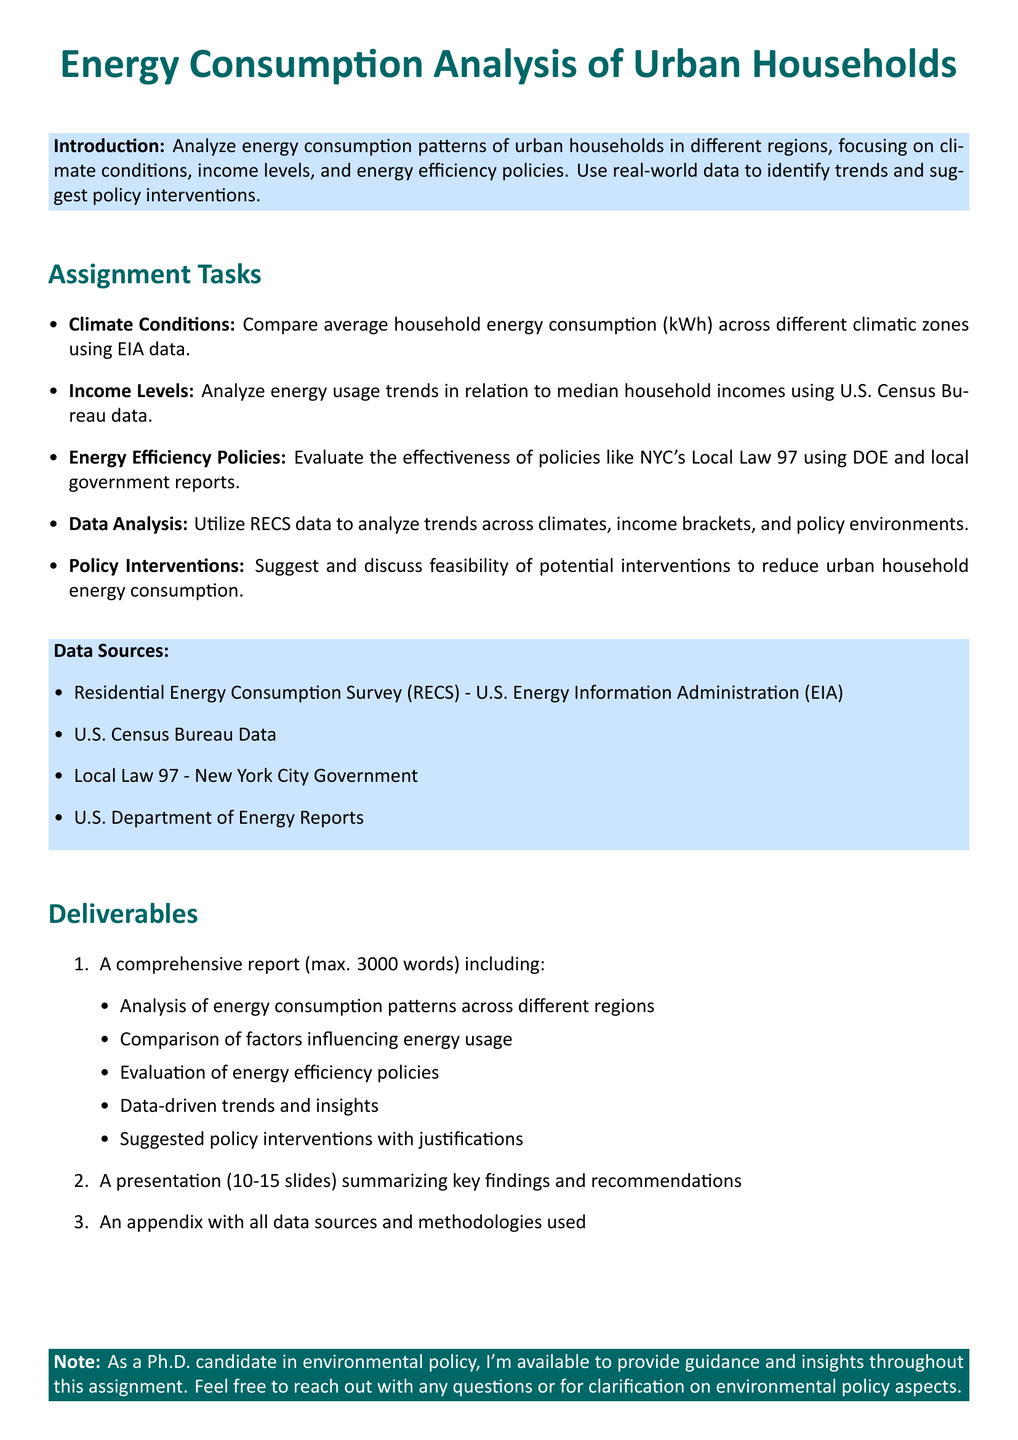What is the main focus of the assignment? The assignment focuses on analyzing energy consumption patterns of urban households in different regions, considering factors such as climate, income levels, and policies.
Answer: Energy consumption patterns What data source is used for climate conditions analysis? The data source used for comparing household energy consumption across climatic zones is the EIA data.
Answer: EIA data How many words is the maximum limit for the report? The document specifies a maximum word limit for the report.
Answer: 3000 words What policy is evaluated in the assignment tasks? The assignment includes an evaluation of NYC's Local Law 97 in relation to energy efficiency.
Answer: NYC's Local Law 97 Which data source provides information on median household incomes? The U.S. Census Bureau Data is the source for median household incomes analysis.
Answer: U.S. Census Bureau Data How many slides should the presentation contain? The document states a specific range for the number of slides in the presentation.
Answer: 10-15 slides Which organization's report is mentioned as a data source? The U.S. Department of Energy Reports are cited as a data source for the assignment.
Answer: U.S. Department of Energy Reports What are the suggested deliverables for this assignment? The deliverables include a comprehensive report, a presentation, and an appendix with data sources.
Answer: Report, presentation, appendix What is the color of the main title in the document? The document specifies the color of the main title used for the assignment.
Answer: maincolor 